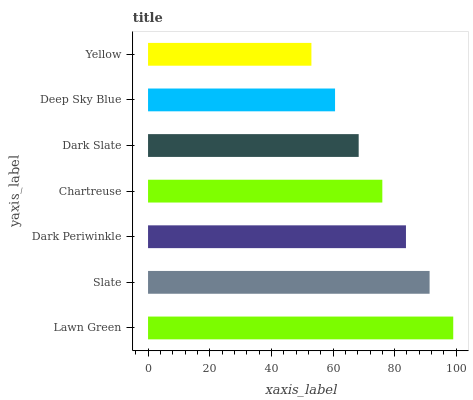Is Yellow the minimum?
Answer yes or no. Yes. Is Lawn Green the maximum?
Answer yes or no. Yes. Is Slate the minimum?
Answer yes or no. No. Is Slate the maximum?
Answer yes or no. No. Is Lawn Green greater than Slate?
Answer yes or no. Yes. Is Slate less than Lawn Green?
Answer yes or no. Yes. Is Slate greater than Lawn Green?
Answer yes or no. No. Is Lawn Green less than Slate?
Answer yes or no. No. Is Chartreuse the high median?
Answer yes or no. Yes. Is Chartreuse the low median?
Answer yes or no. Yes. Is Yellow the high median?
Answer yes or no. No. Is Yellow the low median?
Answer yes or no. No. 